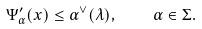Convert formula to latex. <formula><loc_0><loc_0><loc_500><loc_500>\Psi ^ { \prime } _ { \alpha } ( x ) \leq \alpha ^ { \vee } ( \lambda ) , \quad \alpha \in \Sigma .</formula> 